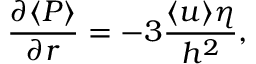Convert formula to latex. <formula><loc_0><loc_0><loc_500><loc_500>\frac { \partial \langle P \rangle } { \partial r } = - 3 \frac { \langle u \rangle \eta } { h ^ { 2 } } ,</formula> 